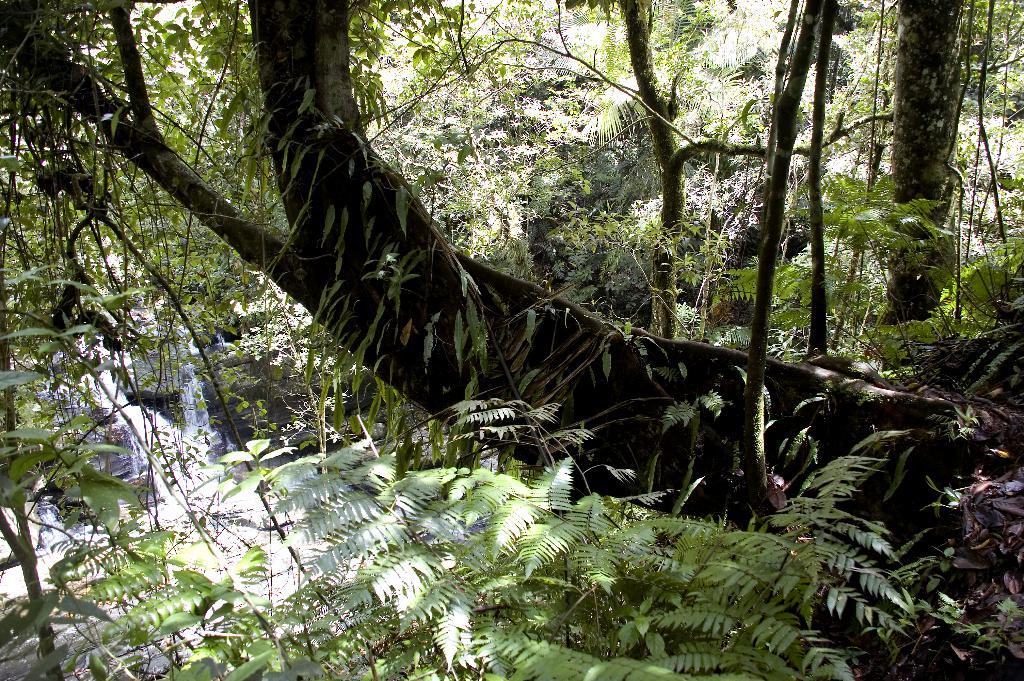What type of vegetation can be seen in the image? There are trees in the image. What natural element is visible in the image? There is water visible in the image. What type of toothbrush is being used to clean the property in the image? There is no toothbrush or property visible in the image. What selection of items can be seen in the image? The image only shows trees and water, so there is no selection of items to describe. 